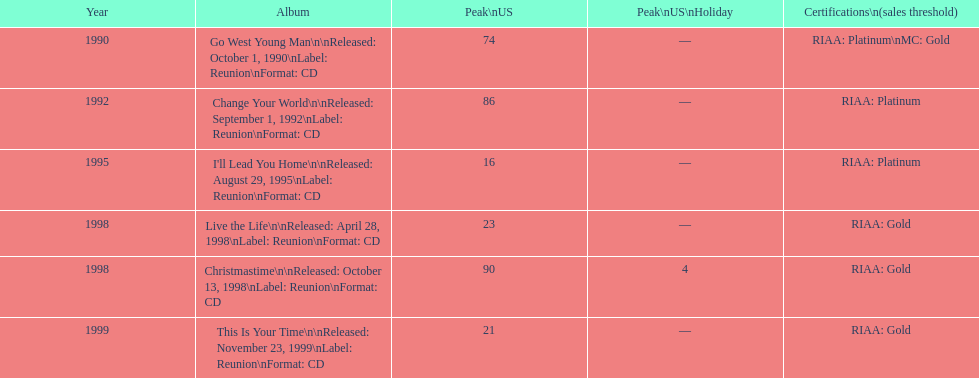Write the full table. {'header': ['Year', 'Album', 'Peak\\nUS', 'Peak\\nUS\\nHoliday', 'Certifications\\n(sales threshold)'], 'rows': [['1990', 'Go West Young Man\\n\\nReleased: October 1, 1990\\nLabel: Reunion\\nFormat: CD', '74', '—', 'RIAA: Platinum\\nMC: Gold'], ['1992', 'Change Your World\\n\\nReleased: September 1, 1992\\nLabel: Reunion\\nFormat: CD', '86', '—', 'RIAA: Platinum'], ['1995', "I'll Lead You Home\\n\\nReleased: August 29, 1995\\nLabel: Reunion\\nFormat: CD", '16', '—', 'RIAA: Platinum'], ['1998', 'Live the Life\\n\\nReleased: April 28, 1998\\nLabel: Reunion\\nFormat: CD', '23', '—', 'RIAA: Gold'], ['1998', 'Christmastime\\n\\nReleased: October 13, 1998\\nLabel: Reunion\\nFormat: CD', '90', '4', 'RIAA: Gold'], ['1999', 'This Is Your Time\\n\\nReleased: November 23, 1999\\nLabel: Reunion\\nFormat: CD', '21', '—', 'RIAA: Gold']]} What is the number of songs listed from 1998? 2. 